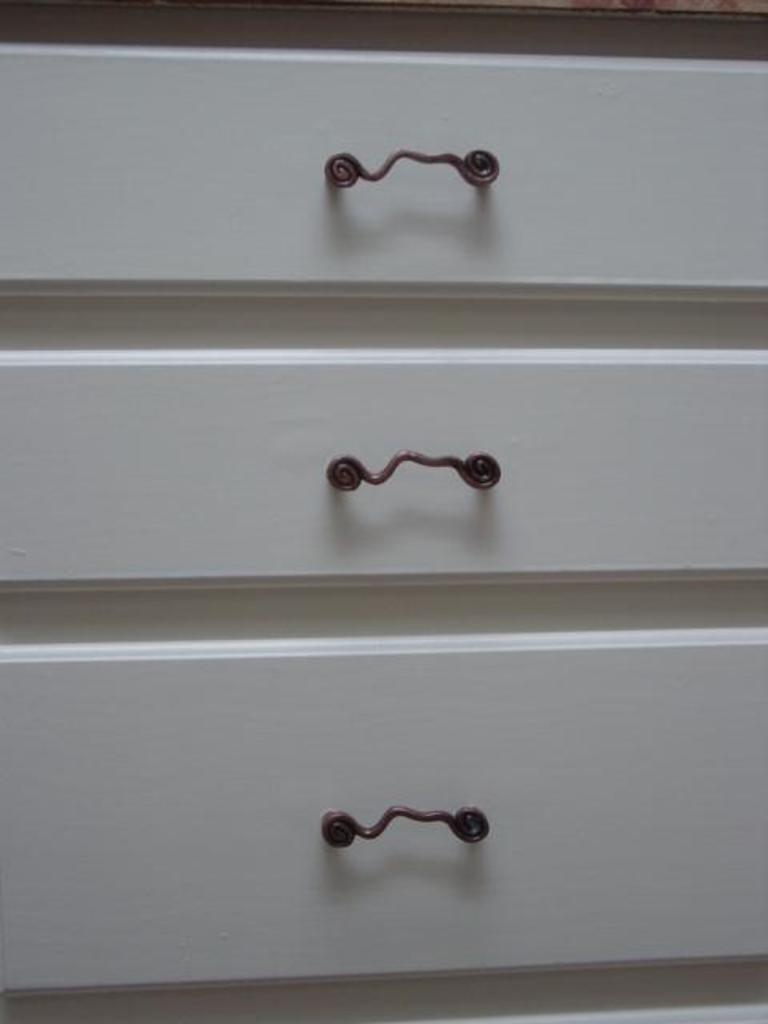What piece of furniture is present in the image? There is a desk in the image. What type of scent can be detected coming from the desk in the image? There is no information about a scent in the image, as it only mentions the presence of a desk. 